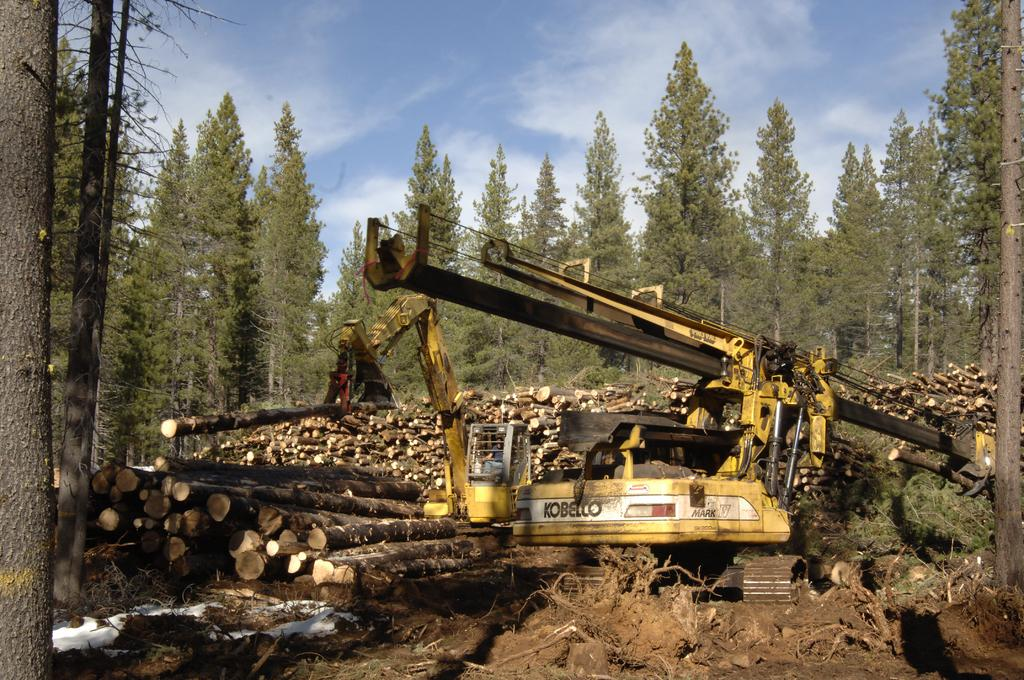<image>
Create a compact narrative representing the image presented. Yellow truck which has the word "Kobello" on it. 